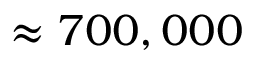<formula> <loc_0><loc_0><loc_500><loc_500>\approx 7 0 0 , 0 0 0</formula> 